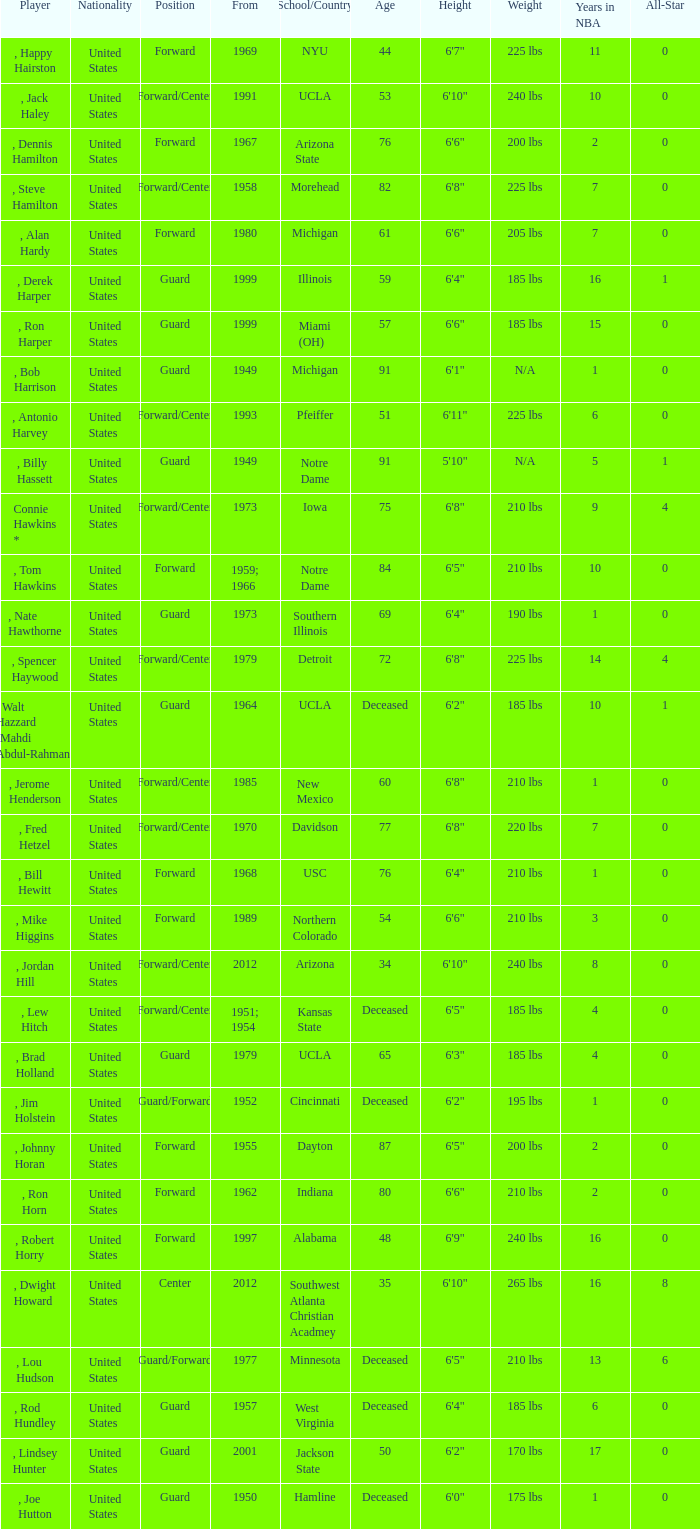Which player started in 2001? , Lindsey Hunter. 